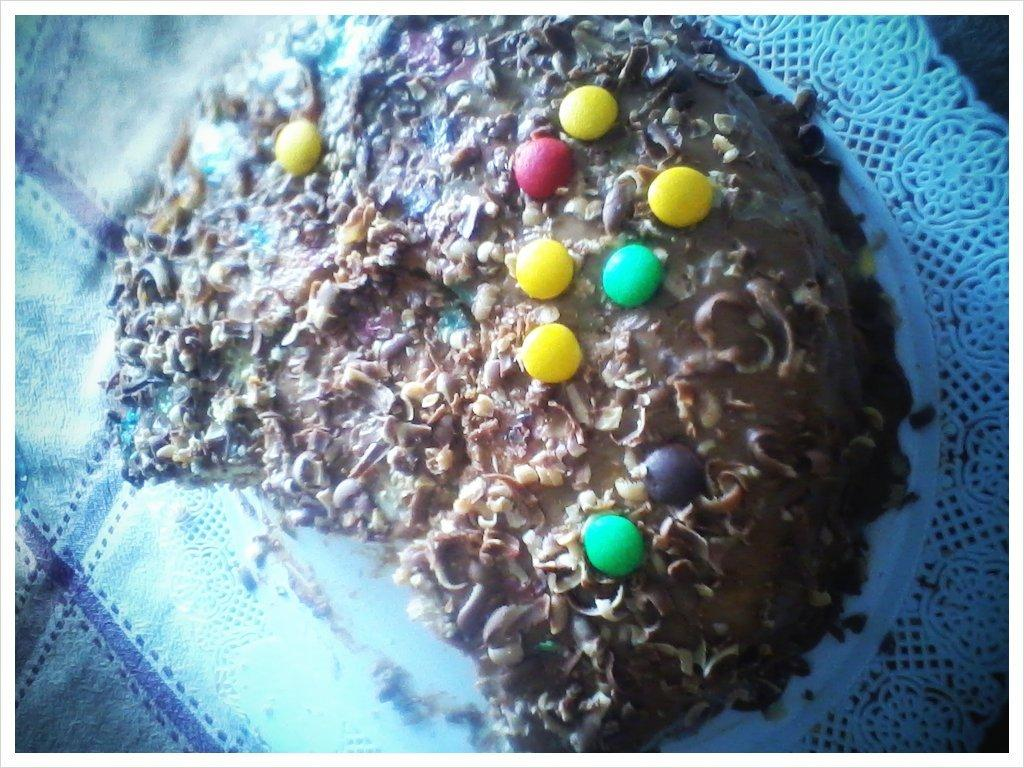What type of food items can be seen in the image? There are food items in the image. What distinguishing features do these food items have? The food items have gems and choco chips on them. Are there any other items present on the food items? Yes, there are other items on the food items. What type of flower can be seen growing on the ice in the image? There is no ice or flower present in the image. 